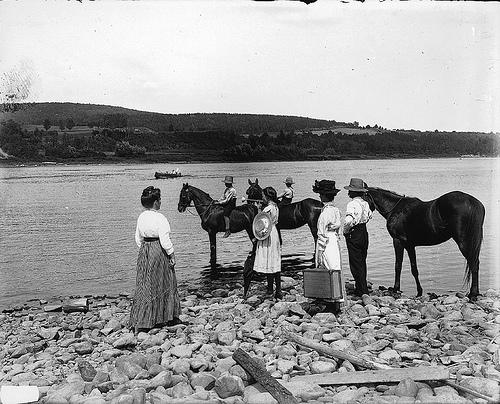What event is this?
Answer briefly. Wild west. How many horses are pictured?
Be succinct. 3. Do the horses have saddles on?
Give a very brief answer. No. Whose family is this?
Keep it brief. Unsure. Who put out the hay?
Write a very short answer. Farmers. 